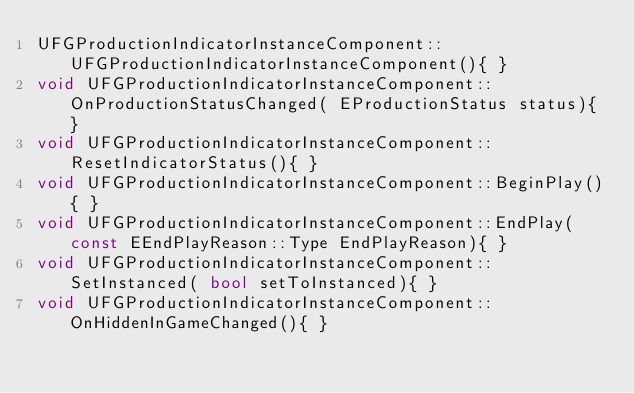Convert code to text. <code><loc_0><loc_0><loc_500><loc_500><_C++_>UFGProductionIndicatorInstanceComponent::UFGProductionIndicatorInstanceComponent(){ }
void UFGProductionIndicatorInstanceComponent::OnProductionStatusChanged( EProductionStatus status){ }
void UFGProductionIndicatorInstanceComponent::ResetIndicatorStatus(){ }
void UFGProductionIndicatorInstanceComponent::BeginPlay(){ }
void UFGProductionIndicatorInstanceComponent::EndPlay( const EEndPlayReason::Type EndPlayReason){ }
void UFGProductionIndicatorInstanceComponent::SetInstanced( bool setToInstanced){ }
void UFGProductionIndicatorInstanceComponent::OnHiddenInGameChanged(){ }
</code> 